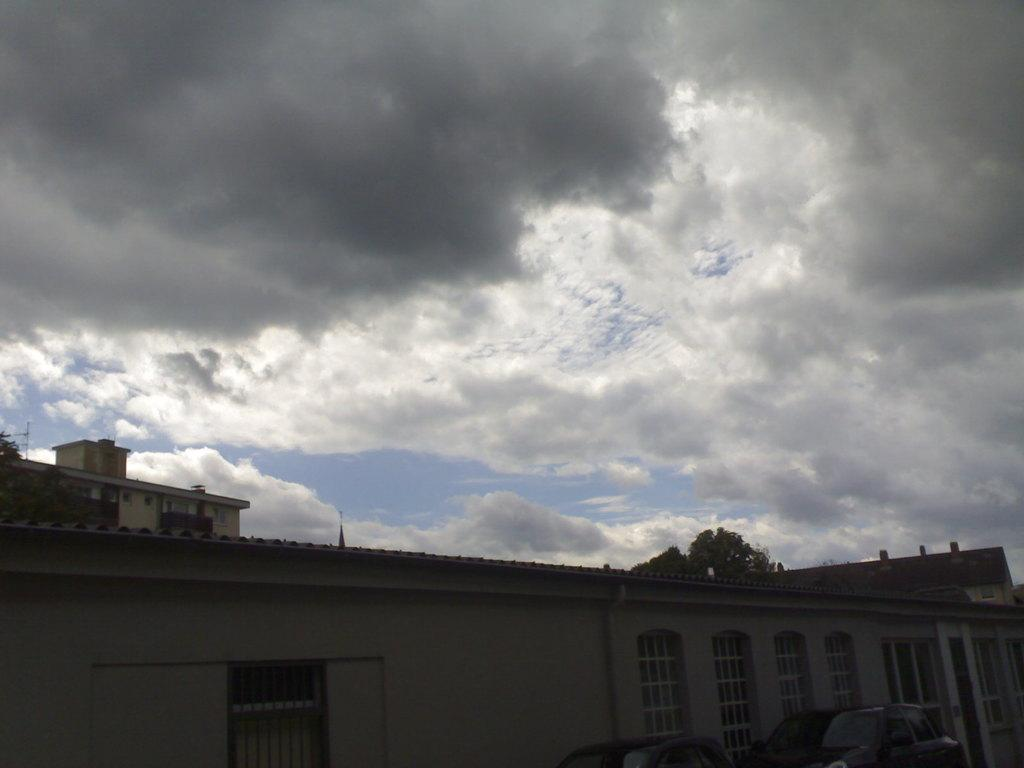What type of structure is visible in the image? There is a building in the image. What other natural elements can be seen in the image? There are trees in the image. How would you describe the weather based on the sky in the image? The sky is cloudy in the image. Can you see any tigers walking through the snow in the image? There are no tigers or snow present in the image; it features a building and trees with a cloudy sky. 